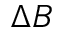Convert formula to latex. <formula><loc_0><loc_0><loc_500><loc_500>\Delta B</formula> 